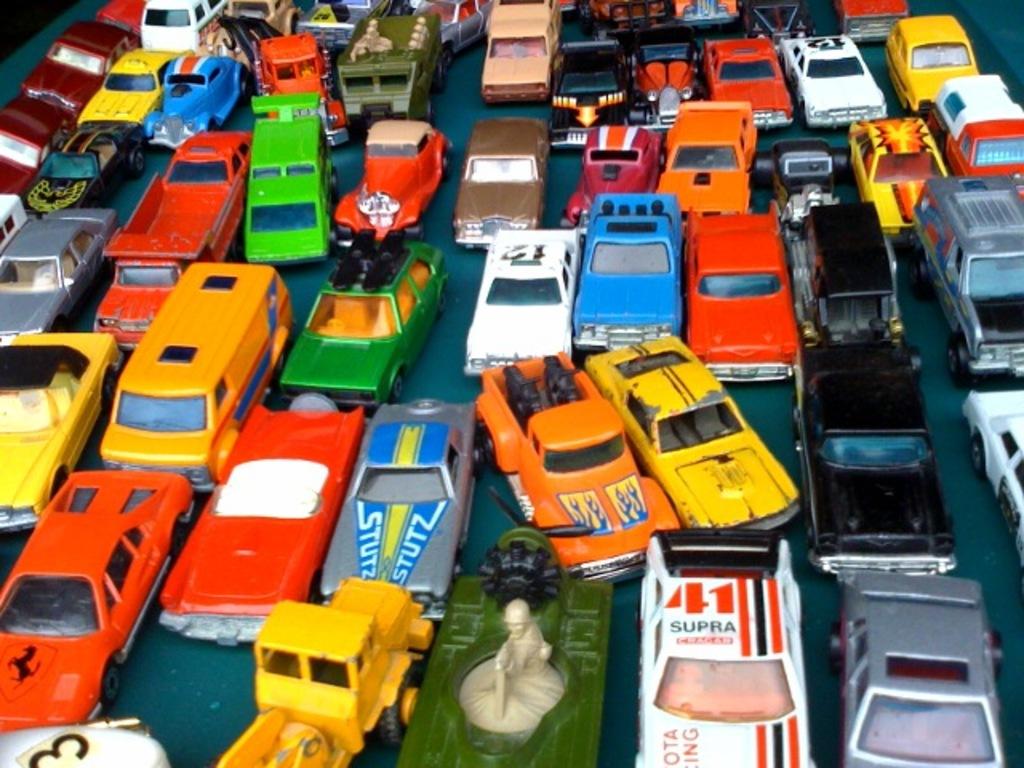What number is on the supra?
Provide a short and direct response. 41. What does it say on the hood of the car to the left of the orange truck with flames?
Offer a terse response. Stutz. 